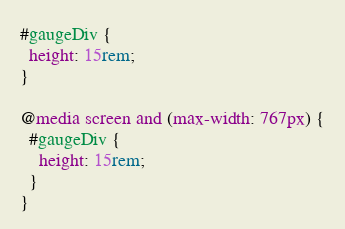Convert code to text. <code><loc_0><loc_0><loc_500><loc_500><_CSS_>#gaugeDiv {
  height: 15rem;
}

@media screen and (max-width: 767px) {
  #gaugeDiv {
    height: 15rem;
  }
}
</code> 